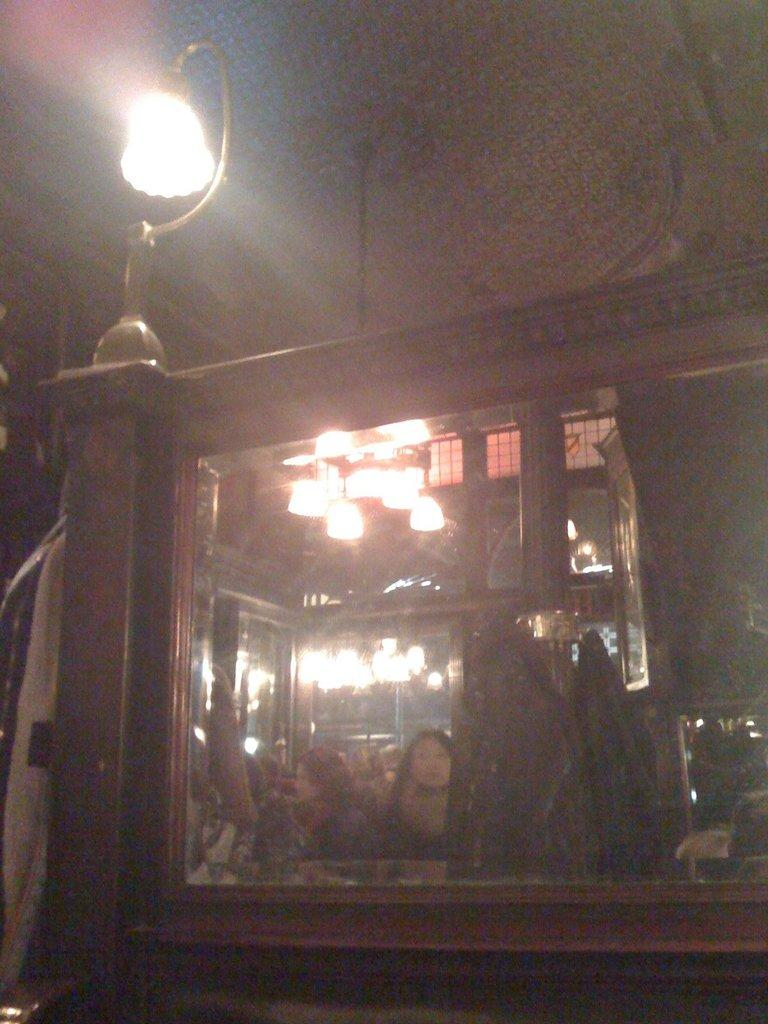What can be seen in the image that provides illumination? There is a light in the image. What object is attached to the wall in the image? There is a mirror on the wall in the image. How many steps are visible in the image? There are no steps visible in the image. What thought process can be observed in the mirror in the image? There is no thought process visible in the mirror, as it is a reflection of the surroundings and not a sentient being. 